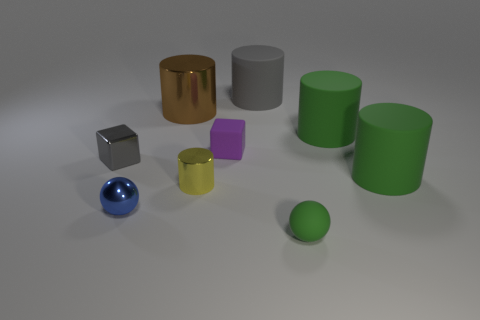Subtract 2 cylinders. How many cylinders are left? 3 Subtract all brown cylinders. How many cylinders are left? 4 Subtract all large gray cylinders. How many cylinders are left? 4 Subtract all purple cylinders. Subtract all green balls. How many cylinders are left? 5 Add 1 tiny yellow metallic cylinders. How many objects exist? 10 Subtract all blocks. How many objects are left? 7 Add 6 metallic things. How many metallic things are left? 10 Add 8 blue spheres. How many blue spheres exist? 9 Subtract 0 red cubes. How many objects are left? 9 Subtract all small yellow blocks. Subtract all gray blocks. How many objects are left? 8 